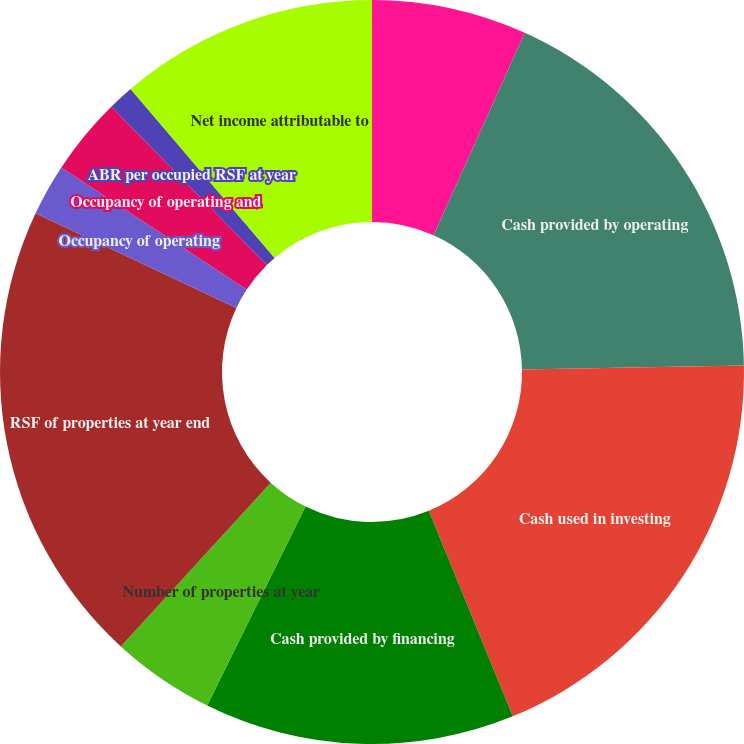<chart> <loc_0><loc_0><loc_500><loc_500><pie_chart><fcel>(Dollars in thousands except<fcel>Cash provided by operating<fcel>Cash used in investing<fcel>Cash provided by financing<fcel>Number of properties at year<fcel>RSF of properties at year end<fcel>Occupancy of operating<fcel>Occupancy of operating and<fcel>ABR per occupied RSF at year<fcel>Net income attributable to<nl><fcel>6.74%<fcel>17.98%<fcel>19.1%<fcel>13.48%<fcel>4.49%<fcel>20.22%<fcel>2.25%<fcel>3.37%<fcel>1.12%<fcel>11.24%<nl></chart> 